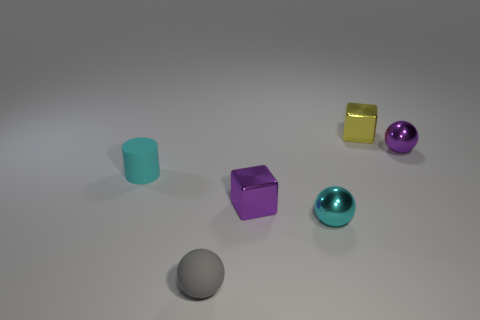What emotion does this arrangement of objects evoke? The arrangement has a minimalist and balanced composition, evoking a sense of calm, order, and modernity. The cool hues of the objects contribute to a tranquil and contemplative mood. 